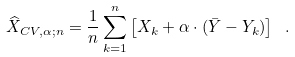Convert formula to latex. <formula><loc_0><loc_0><loc_500><loc_500>\widehat { X } _ { C V , \alpha ; n } = \frac { 1 } { n } \sum _ { k = 1 } ^ { n } \left [ X _ { k } + \alpha \cdot ( \bar { Y } - Y _ { k } ) \right ] \ .</formula> 